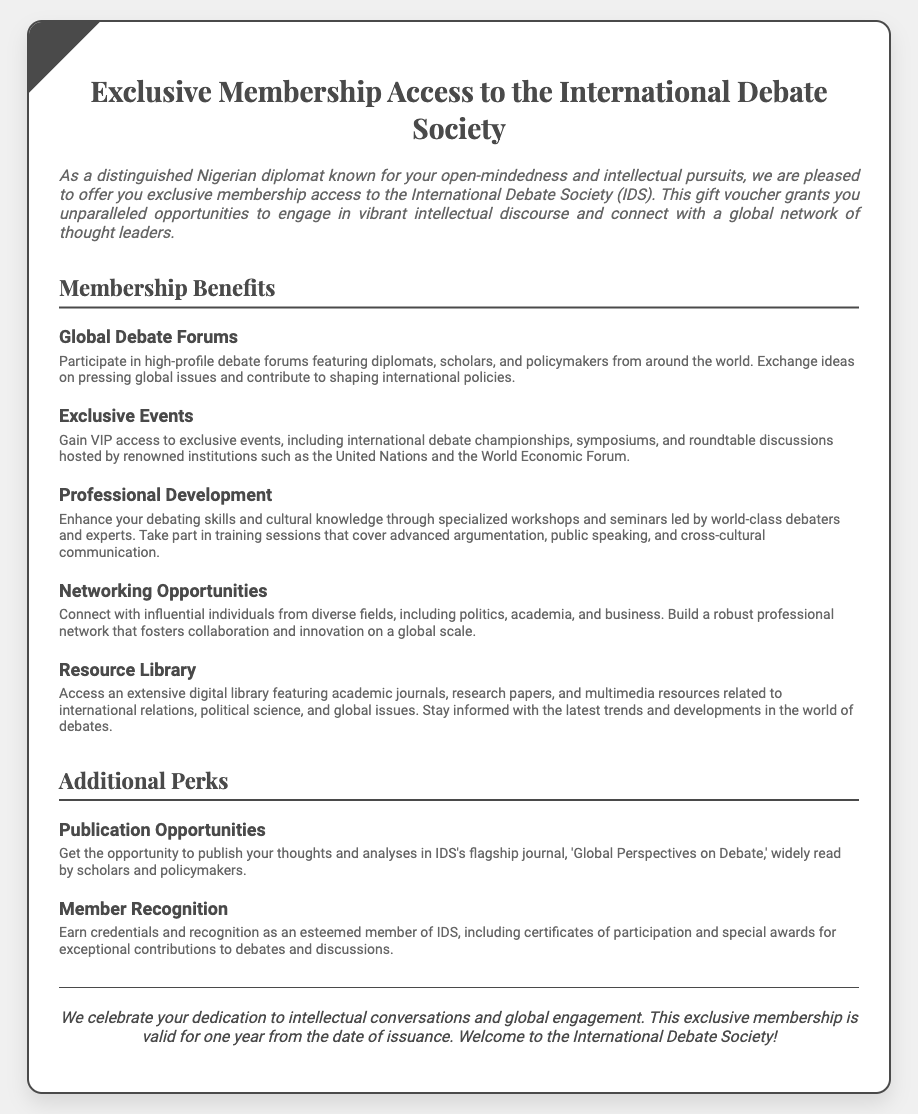What is the title of the voucher? The title of the voucher is explicitly stated at the top of the document.
Answer: Exclusive Membership Access to the International Debate Society How long is the membership valid? The document mentions the validity period of the exclusive membership specifically.
Answer: One year Who are typical participants in the global debate forums? The document lists the types of individuals participating in debates, which are indicated in the text.
Answer: Diplomats, scholars, and policymakers What is one of the exclusive events mentioned? The document specifies the events members have access to, highlighting one such event.
Answer: International debate championships What kind of library access is offered? The voucher states the type of resources available to members in the document.
Answer: Digital library What type of recognition can members earn? The document describes the type of recognition members receive for their contributions.
Answer: Certificates of participation What is the flagship journal's name? The voucher provides the specific name of the publication associated with the society.
Answer: Global Perspectives on Debate What is a benefit related to professional development? The document highlights a specific aspect of professional development that members can expect.
Answer: Specialized workshops and seminars What color is the voucher's background? The visual design of the voucher's background color is directly stated.
Answer: White 